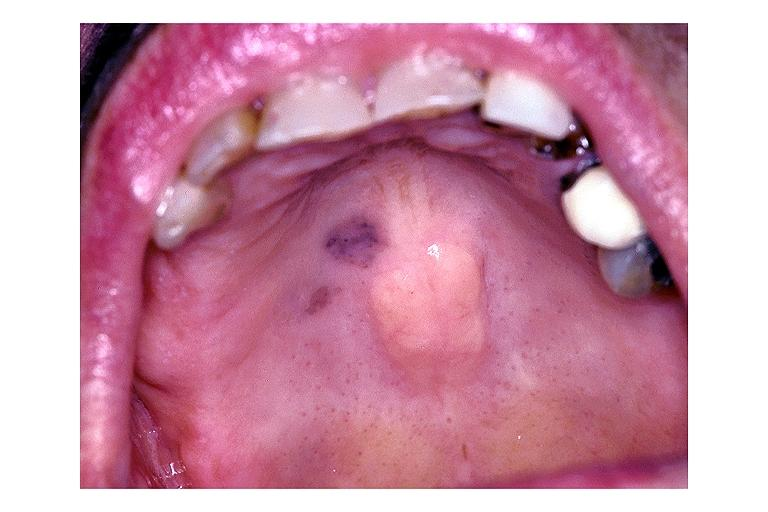does this image show focal melanosis?
Answer the question using a single word or phrase. Yes 